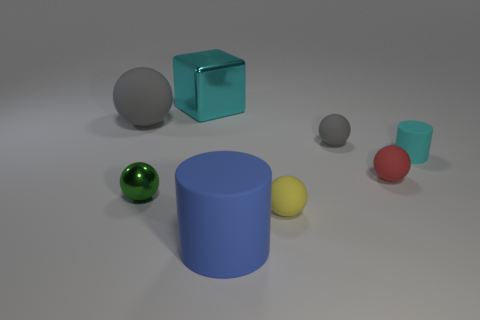Subtract all matte balls. How many balls are left? 1 Subtract all cyan cylinders. How many cylinders are left? 1 Add 1 metal cylinders. How many objects exist? 9 Subtract all cylinders. How many objects are left? 6 Subtract 3 spheres. How many spheres are left? 2 Add 2 rubber objects. How many rubber objects exist? 8 Subtract 1 cyan cylinders. How many objects are left? 7 Subtract all green balls. Subtract all cyan cylinders. How many balls are left? 4 Subtract all red spheres. How many cyan cylinders are left? 1 Subtract all rubber spheres. Subtract all large cyan cylinders. How many objects are left? 4 